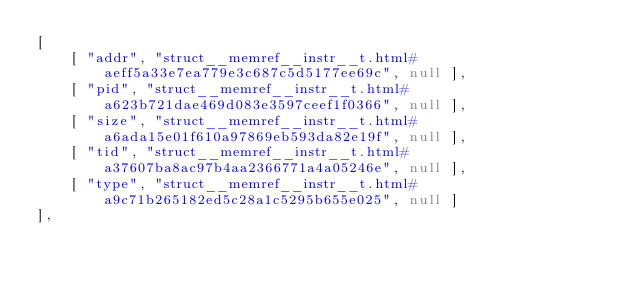<code> <loc_0><loc_0><loc_500><loc_500><_JavaScript_>[
    [ "addr", "struct__memref__instr__t.html#aeff5a33e7ea779e3c687c5d5177ee69c", null ],
    [ "pid", "struct__memref__instr__t.html#a623b721dae469d083e3597ceef1f0366", null ],
    [ "size", "struct__memref__instr__t.html#a6ada15e01f610a97869eb593da82e19f", null ],
    [ "tid", "struct__memref__instr__t.html#a37607ba8ac97b4aa2366771a4a05246e", null ],
    [ "type", "struct__memref__instr__t.html#a9c71b265182ed5c28a1c5295b655e025", null ]
],</code> 